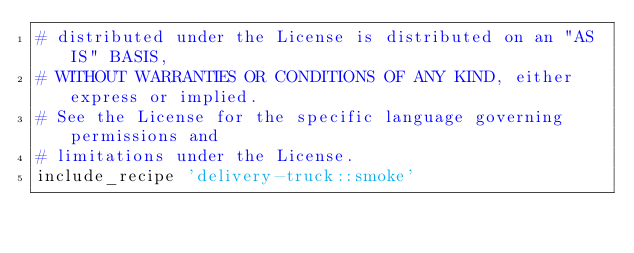<code> <loc_0><loc_0><loc_500><loc_500><_Ruby_># distributed under the License is distributed on an "AS IS" BASIS,
# WITHOUT WARRANTIES OR CONDITIONS OF ANY KIND, either express or implied.
# See the License for the specific language governing permissions and
# limitations under the License.
include_recipe 'delivery-truck::smoke'
</code> 